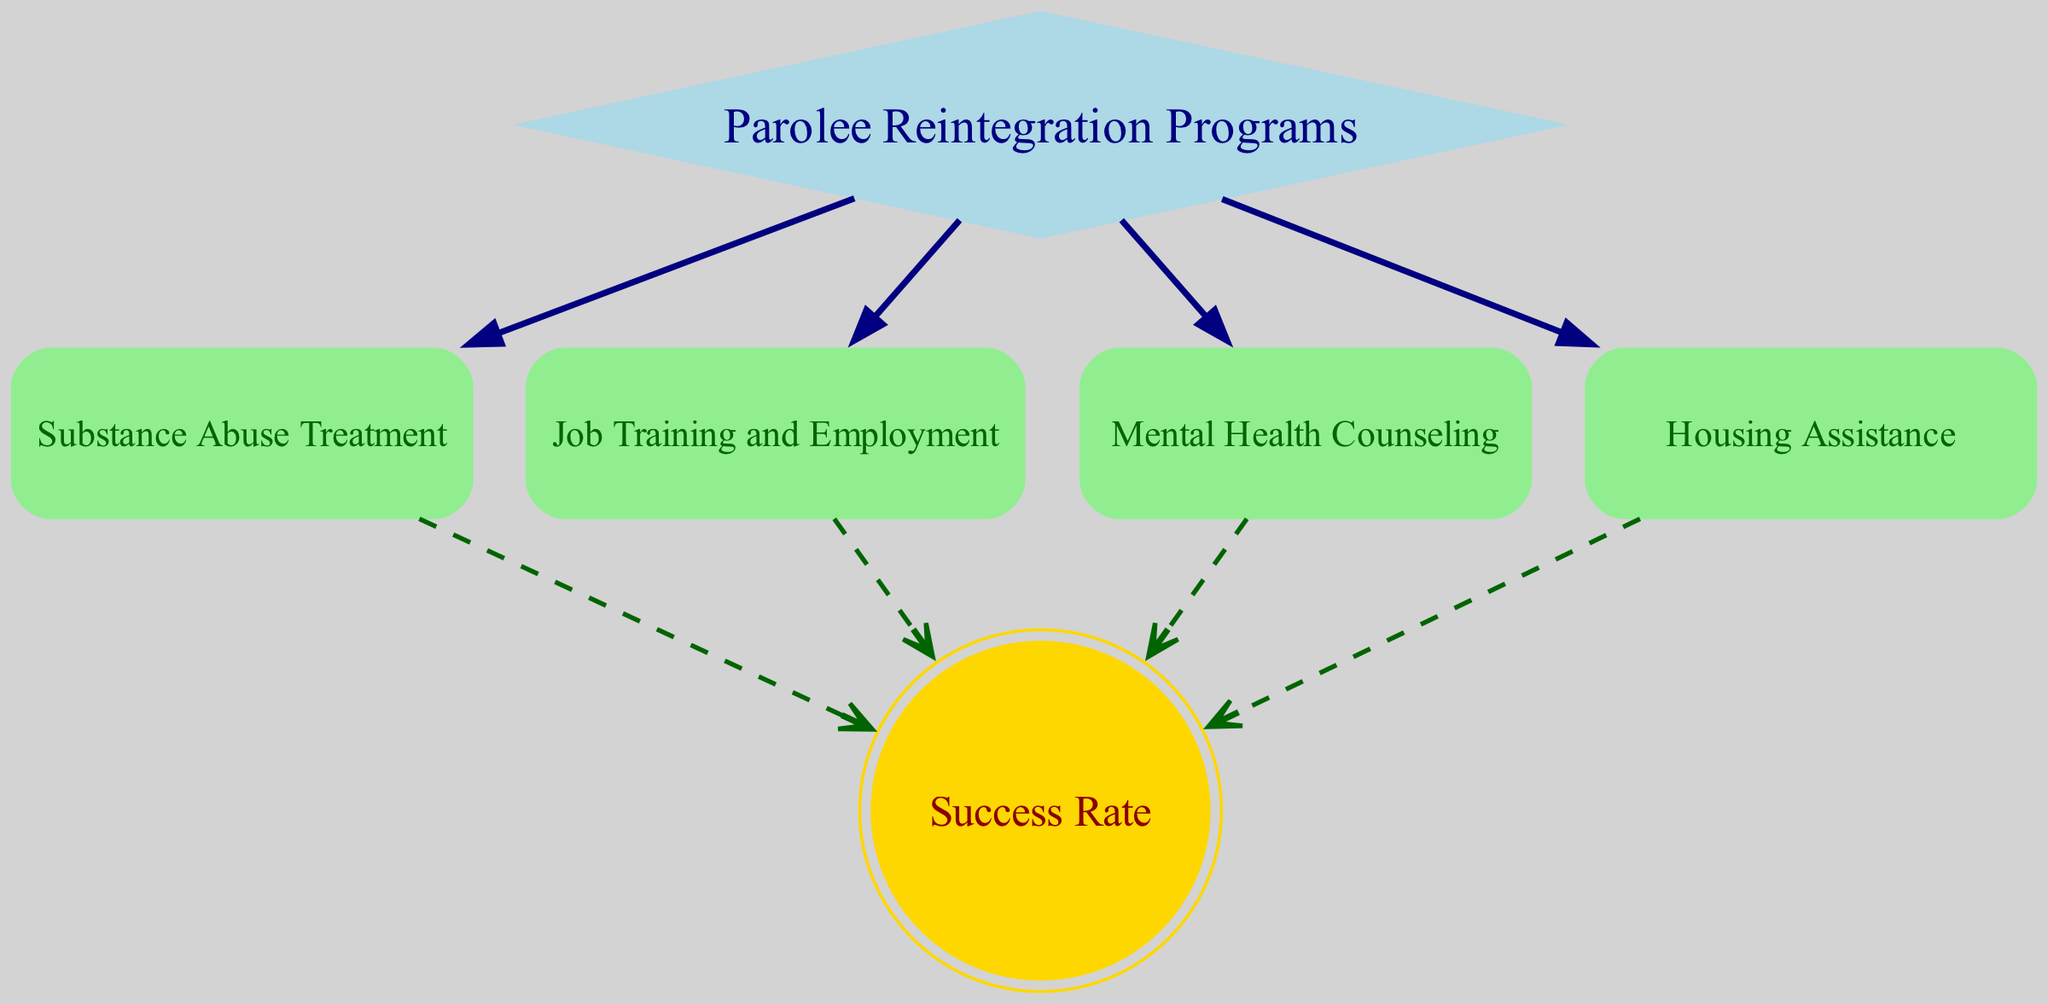What are the different parolee reintegration programs represented in the diagram? The diagram lists the parolee reintegration programs as Substance Abuse Treatment, Job Training and Employment, Mental Health Counseling, and Housing Assistance. These are depicted as nodes connected to the main node "Parolee Reintegration Programs."
Answer: Substance Abuse Treatment, Job Training and Employment, Mental Health Counseling, Housing Assistance Which node has the highest level of importance in the diagram? The "Parolee Reintegration Programs" node is the primary node, as it's the starting point from which all the other programs derive. It serves as a categorization for the various programs showing the flow of integrated support.
Answer: Parolee Reintegration Programs What is the final outcome node in the directed graph? The directed graph leads to a single outcome node, which is "Success Rate." This represents the ultimate measure of effectiveness for the programs.
Answer: Success Rate How many edges are there in total in the directed graph? By counting the edges represented in the diagram, there are a total of eight connections. Each program connects to the Success Rate, while all programs connect back to the main node.
Answer: 8 Which programs are directly linked to the Success Rate node? The programs that lead directly to the Success Rate node are Substance Abuse Treatment, Job Training and Employment, Mental Health Counseling, and Housing Assistance. Each has a direct connection representing their impact on the success of reintegration.
Answer: Substance Abuse Treatment, Job Training and Employment, Mental Health Counseling, Housing Assistance If Substance Abuse Treatment is improved, which outcome will it influence? Improving Substance Abuse Treatment will directly affect the "Success Rate" node, as it is one of the programs contributing to overall success in reintegration efforts. Hence, any improvement in this program will likely enhance the success rate for parolees.
Answer: Success Rate What type of graph is depicted in this diagram? The structure is identified as a directed graph due to the arrows indicating the flow of influence from the programs towards the outcome (Success Rate), showing a unidirectional relationship.
Answer: Directed Graph Which node is represented by a double circle? The representation of the "Success Rate" node in a double circle highlights its significance as the ultimate goal for the reintegration programs. This is a distinctive feature in the graph structure.
Answer: Success Rate 